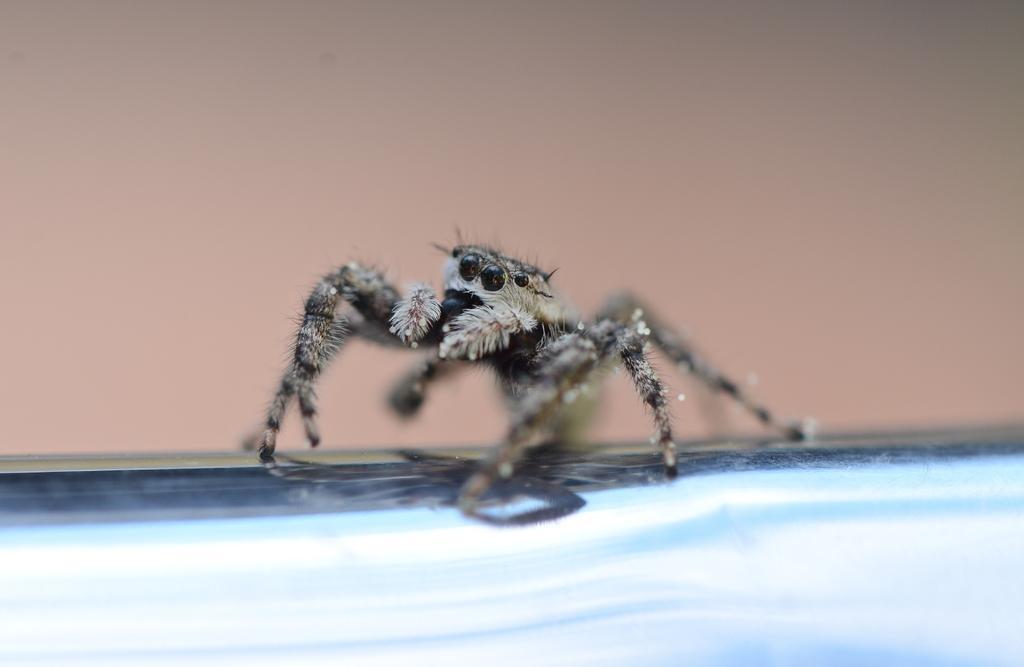Could you give a brief overview of what you see in this image? In this picture I can see a spider and I can see plain background. 